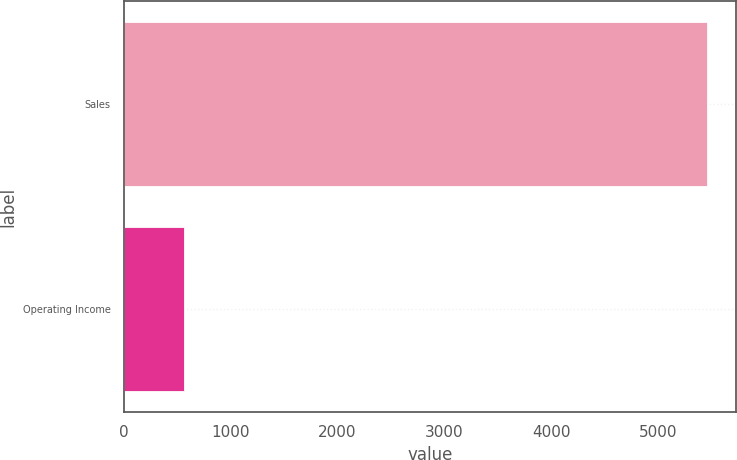Convert chart. <chart><loc_0><loc_0><loc_500><loc_500><bar_chart><fcel>Sales<fcel>Operating Income<nl><fcel>5460<fcel>560<nl></chart> 